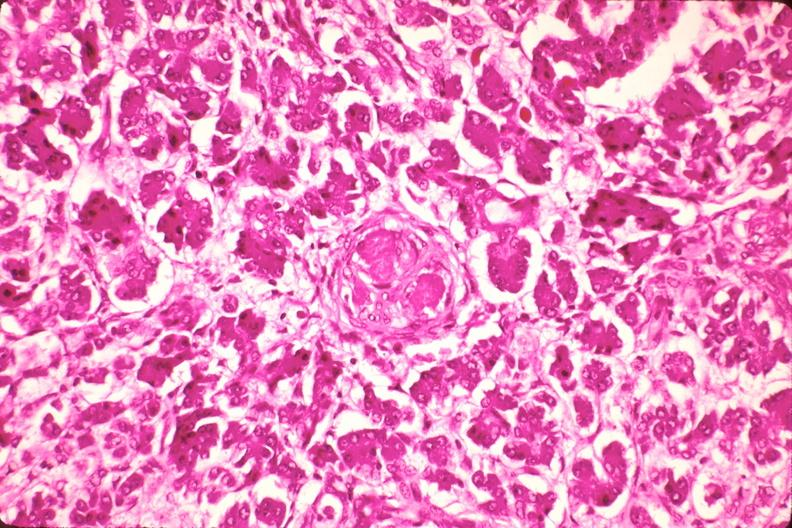s lateral view present?
Answer the question using a single word or phrase. No 